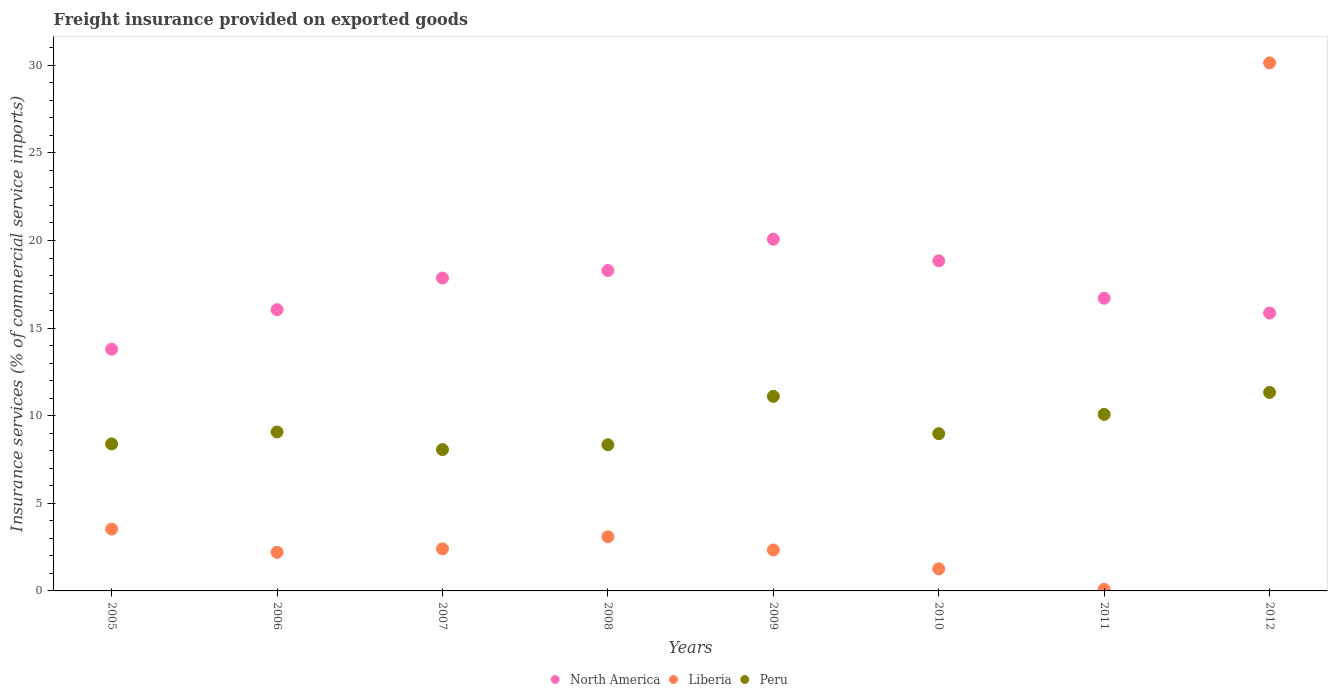How many different coloured dotlines are there?
Ensure brevity in your answer.  3. What is the freight insurance provided on exported goods in Liberia in 2012?
Give a very brief answer. 30.14. Across all years, what is the maximum freight insurance provided on exported goods in Peru?
Offer a terse response. 11.33. Across all years, what is the minimum freight insurance provided on exported goods in Liberia?
Your response must be concise. 0.09. In which year was the freight insurance provided on exported goods in Liberia maximum?
Provide a short and direct response. 2012. What is the total freight insurance provided on exported goods in North America in the graph?
Provide a short and direct response. 137.48. What is the difference between the freight insurance provided on exported goods in Liberia in 2010 and that in 2011?
Make the answer very short. 1.17. What is the difference between the freight insurance provided on exported goods in North America in 2011 and the freight insurance provided on exported goods in Liberia in 2007?
Make the answer very short. 14.3. What is the average freight insurance provided on exported goods in Liberia per year?
Make the answer very short. 5.63. In the year 2005, what is the difference between the freight insurance provided on exported goods in Peru and freight insurance provided on exported goods in Liberia?
Give a very brief answer. 4.86. What is the ratio of the freight insurance provided on exported goods in Liberia in 2006 to that in 2009?
Keep it short and to the point. 0.94. What is the difference between the highest and the second highest freight insurance provided on exported goods in Liberia?
Make the answer very short. 26.61. What is the difference between the highest and the lowest freight insurance provided on exported goods in Peru?
Make the answer very short. 3.26. In how many years, is the freight insurance provided on exported goods in Peru greater than the average freight insurance provided on exported goods in Peru taken over all years?
Provide a short and direct response. 3. Does the freight insurance provided on exported goods in North America monotonically increase over the years?
Your answer should be very brief. No. Is the freight insurance provided on exported goods in Liberia strictly greater than the freight insurance provided on exported goods in North America over the years?
Your response must be concise. No. Is the freight insurance provided on exported goods in North America strictly less than the freight insurance provided on exported goods in Peru over the years?
Make the answer very short. No. How many years are there in the graph?
Your answer should be compact. 8. Are the values on the major ticks of Y-axis written in scientific E-notation?
Your answer should be very brief. No. Does the graph contain any zero values?
Your response must be concise. No. Where does the legend appear in the graph?
Provide a short and direct response. Bottom center. What is the title of the graph?
Provide a succinct answer. Freight insurance provided on exported goods. What is the label or title of the Y-axis?
Your response must be concise. Insurance services (% of commercial service imports). What is the Insurance services (% of commercial service imports) of North America in 2005?
Your answer should be very brief. 13.8. What is the Insurance services (% of commercial service imports) in Liberia in 2005?
Make the answer very short. 3.53. What is the Insurance services (% of commercial service imports) in Peru in 2005?
Give a very brief answer. 8.39. What is the Insurance services (% of commercial service imports) in North America in 2006?
Make the answer very short. 16.05. What is the Insurance services (% of commercial service imports) in Liberia in 2006?
Your response must be concise. 2.2. What is the Insurance services (% of commercial service imports) of Peru in 2006?
Your answer should be compact. 9.07. What is the Insurance services (% of commercial service imports) of North America in 2007?
Offer a very short reply. 17.86. What is the Insurance services (% of commercial service imports) of Liberia in 2007?
Your answer should be very brief. 2.4. What is the Insurance services (% of commercial service imports) in Peru in 2007?
Make the answer very short. 8.07. What is the Insurance services (% of commercial service imports) in North America in 2008?
Your answer should be compact. 18.29. What is the Insurance services (% of commercial service imports) in Liberia in 2008?
Your answer should be compact. 3.09. What is the Insurance services (% of commercial service imports) of Peru in 2008?
Your answer should be very brief. 8.34. What is the Insurance services (% of commercial service imports) in North America in 2009?
Your answer should be compact. 20.08. What is the Insurance services (% of commercial service imports) in Liberia in 2009?
Provide a short and direct response. 2.34. What is the Insurance services (% of commercial service imports) in Peru in 2009?
Ensure brevity in your answer.  11.1. What is the Insurance services (% of commercial service imports) in North America in 2010?
Offer a very short reply. 18.84. What is the Insurance services (% of commercial service imports) in Liberia in 2010?
Your response must be concise. 1.26. What is the Insurance services (% of commercial service imports) of Peru in 2010?
Offer a terse response. 8.98. What is the Insurance services (% of commercial service imports) of North America in 2011?
Give a very brief answer. 16.7. What is the Insurance services (% of commercial service imports) in Liberia in 2011?
Offer a very short reply. 0.09. What is the Insurance services (% of commercial service imports) of Peru in 2011?
Offer a terse response. 10.08. What is the Insurance services (% of commercial service imports) of North America in 2012?
Your response must be concise. 15.86. What is the Insurance services (% of commercial service imports) in Liberia in 2012?
Offer a very short reply. 30.14. What is the Insurance services (% of commercial service imports) in Peru in 2012?
Make the answer very short. 11.33. Across all years, what is the maximum Insurance services (% of commercial service imports) of North America?
Make the answer very short. 20.08. Across all years, what is the maximum Insurance services (% of commercial service imports) in Liberia?
Your answer should be very brief. 30.14. Across all years, what is the maximum Insurance services (% of commercial service imports) in Peru?
Keep it short and to the point. 11.33. Across all years, what is the minimum Insurance services (% of commercial service imports) in North America?
Keep it short and to the point. 13.8. Across all years, what is the minimum Insurance services (% of commercial service imports) of Liberia?
Your answer should be compact. 0.09. Across all years, what is the minimum Insurance services (% of commercial service imports) in Peru?
Make the answer very short. 8.07. What is the total Insurance services (% of commercial service imports) in North America in the graph?
Offer a terse response. 137.48. What is the total Insurance services (% of commercial service imports) of Liberia in the graph?
Make the answer very short. 45.05. What is the total Insurance services (% of commercial service imports) of Peru in the graph?
Ensure brevity in your answer.  75.35. What is the difference between the Insurance services (% of commercial service imports) of North America in 2005 and that in 2006?
Offer a very short reply. -2.26. What is the difference between the Insurance services (% of commercial service imports) of Liberia in 2005 and that in 2006?
Provide a succinct answer. 1.33. What is the difference between the Insurance services (% of commercial service imports) in Peru in 2005 and that in 2006?
Ensure brevity in your answer.  -0.68. What is the difference between the Insurance services (% of commercial service imports) in North America in 2005 and that in 2007?
Keep it short and to the point. -4.06. What is the difference between the Insurance services (% of commercial service imports) in Liberia in 2005 and that in 2007?
Your answer should be compact. 1.13. What is the difference between the Insurance services (% of commercial service imports) of Peru in 2005 and that in 2007?
Offer a very short reply. 0.32. What is the difference between the Insurance services (% of commercial service imports) of North America in 2005 and that in 2008?
Your answer should be very brief. -4.49. What is the difference between the Insurance services (% of commercial service imports) in Liberia in 2005 and that in 2008?
Offer a very short reply. 0.44. What is the difference between the Insurance services (% of commercial service imports) in Peru in 2005 and that in 2008?
Your response must be concise. 0.05. What is the difference between the Insurance services (% of commercial service imports) of North America in 2005 and that in 2009?
Keep it short and to the point. -6.28. What is the difference between the Insurance services (% of commercial service imports) of Liberia in 2005 and that in 2009?
Keep it short and to the point. 1.19. What is the difference between the Insurance services (% of commercial service imports) of Peru in 2005 and that in 2009?
Ensure brevity in your answer.  -2.72. What is the difference between the Insurance services (% of commercial service imports) in North America in 2005 and that in 2010?
Your answer should be very brief. -5.04. What is the difference between the Insurance services (% of commercial service imports) of Liberia in 2005 and that in 2010?
Provide a short and direct response. 2.27. What is the difference between the Insurance services (% of commercial service imports) of Peru in 2005 and that in 2010?
Your answer should be very brief. -0.59. What is the difference between the Insurance services (% of commercial service imports) of North America in 2005 and that in 2011?
Your answer should be very brief. -2.91. What is the difference between the Insurance services (% of commercial service imports) in Liberia in 2005 and that in 2011?
Provide a short and direct response. 3.44. What is the difference between the Insurance services (% of commercial service imports) of Peru in 2005 and that in 2011?
Make the answer very short. -1.69. What is the difference between the Insurance services (% of commercial service imports) of North America in 2005 and that in 2012?
Your answer should be compact. -2.06. What is the difference between the Insurance services (% of commercial service imports) in Liberia in 2005 and that in 2012?
Provide a succinct answer. -26.61. What is the difference between the Insurance services (% of commercial service imports) in Peru in 2005 and that in 2012?
Provide a short and direct response. -2.94. What is the difference between the Insurance services (% of commercial service imports) of North America in 2006 and that in 2007?
Ensure brevity in your answer.  -1.81. What is the difference between the Insurance services (% of commercial service imports) in Liberia in 2006 and that in 2007?
Your answer should be very brief. -0.2. What is the difference between the Insurance services (% of commercial service imports) in Peru in 2006 and that in 2007?
Your answer should be very brief. 1.01. What is the difference between the Insurance services (% of commercial service imports) of North America in 2006 and that in 2008?
Make the answer very short. -2.24. What is the difference between the Insurance services (% of commercial service imports) in Liberia in 2006 and that in 2008?
Provide a short and direct response. -0.89. What is the difference between the Insurance services (% of commercial service imports) of Peru in 2006 and that in 2008?
Your response must be concise. 0.73. What is the difference between the Insurance services (% of commercial service imports) in North America in 2006 and that in 2009?
Your answer should be very brief. -4.02. What is the difference between the Insurance services (% of commercial service imports) of Liberia in 2006 and that in 2009?
Ensure brevity in your answer.  -0.13. What is the difference between the Insurance services (% of commercial service imports) of Peru in 2006 and that in 2009?
Give a very brief answer. -2.03. What is the difference between the Insurance services (% of commercial service imports) of North America in 2006 and that in 2010?
Ensure brevity in your answer.  -2.79. What is the difference between the Insurance services (% of commercial service imports) of Liberia in 2006 and that in 2010?
Keep it short and to the point. 0.94. What is the difference between the Insurance services (% of commercial service imports) in Peru in 2006 and that in 2010?
Offer a very short reply. 0.1. What is the difference between the Insurance services (% of commercial service imports) in North America in 2006 and that in 2011?
Your answer should be compact. -0.65. What is the difference between the Insurance services (% of commercial service imports) in Liberia in 2006 and that in 2011?
Your answer should be very brief. 2.11. What is the difference between the Insurance services (% of commercial service imports) of Peru in 2006 and that in 2011?
Offer a very short reply. -1. What is the difference between the Insurance services (% of commercial service imports) in North America in 2006 and that in 2012?
Your response must be concise. 0.19. What is the difference between the Insurance services (% of commercial service imports) of Liberia in 2006 and that in 2012?
Ensure brevity in your answer.  -27.93. What is the difference between the Insurance services (% of commercial service imports) of Peru in 2006 and that in 2012?
Make the answer very short. -2.26. What is the difference between the Insurance services (% of commercial service imports) in North America in 2007 and that in 2008?
Provide a short and direct response. -0.43. What is the difference between the Insurance services (% of commercial service imports) in Liberia in 2007 and that in 2008?
Ensure brevity in your answer.  -0.69. What is the difference between the Insurance services (% of commercial service imports) of Peru in 2007 and that in 2008?
Keep it short and to the point. -0.27. What is the difference between the Insurance services (% of commercial service imports) in North America in 2007 and that in 2009?
Make the answer very short. -2.22. What is the difference between the Insurance services (% of commercial service imports) in Liberia in 2007 and that in 2009?
Give a very brief answer. 0.06. What is the difference between the Insurance services (% of commercial service imports) of Peru in 2007 and that in 2009?
Give a very brief answer. -3.04. What is the difference between the Insurance services (% of commercial service imports) of North America in 2007 and that in 2010?
Provide a succinct answer. -0.98. What is the difference between the Insurance services (% of commercial service imports) of Liberia in 2007 and that in 2010?
Provide a short and direct response. 1.14. What is the difference between the Insurance services (% of commercial service imports) of Peru in 2007 and that in 2010?
Ensure brevity in your answer.  -0.91. What is the difference between the Insurance services (% of commercial service imports) in North America in 2007 and that in 2011?
Your response must be concise. 1.15. What is the difference between the Insurance services (% of commercial service imports) in Liberia in 2007 and that in 2011?
Ensure brevity in your answer.  2.31. What is the difference between the Insurance services (% of commercial service imports) of Peru in 2007 and that in 2011?
Your response must be concise. -2.01. What is the difference between the Insurance services (% of commercial service imports) of North America in 2007 and that in 2012?
Offer a very short reply. 2. What is the difference between the Insurance services (% of commercial service imports) of Liberia in 2007 and that in 2012?
Provide a short and direct response. -27.73. What is the difference between the Insurance services (% of commercial service imports) of Peru in 2007 and that in 2012?
Your answer should be compact. -3.26. What is the difference between the Insurance services (% of commercial service imports) of North America in 2008 and that in 2009?
Make the answer very short. -1.79. What is the difference between the Insurance services (% of commercial service imports) in Liberia in 2008 and that in 2009?
Offer a very short reply. 0.75. What is the difference between the Insurance services (% of commercial service imports) in Peru in 2008 and that in 2009?
Keep it short and to the point. -2.76. What is the difference between the Insurance services (% of commercial service imports) of North America in 2008 and that in 2010?
Ensure brevity in your answer.  -0.55. What is the difference between the Insurance services (% of commercial service imports) of Liberia in 2008 and that in 2010?
Your answer should be compact. 1.83. What is the difference between the Insurance services (% of commercial service imports) in Peru in 2008 and that in 2010?
Your response must be concise. -0.63. What is the difference between the Insurance services (% of commercial service imports) of North America in 2008 and that in 2011?
Your answer should be compact. 1.58. What is the difference between the Insurance services (% of commercial service imports) of Liberia in 2008 and that in 2011?
Offer a very short reply. 3. What is the difference between the Insurance services (% of commercial service imports) in Peru in 2008 and that in 2011?
Your answer should be compact. -1.74. What is the difference between the Insurance services (% of commercial service imports) in North America in 2008 and that in 2012?
Provide a short and direct response. 2.43. What is the difference between the Insurance services (% of commercial service imports) of Liberia in 2008 and that in 2012?
Provide a succinct answer. -27.05. What is the difference between the Insurance services (% of commercial service imports) in Peru in 2008 and that in 2012?
Offer a very short reply. -2.99. What is the difference between the Insurance services (% of commercial service imports) in North America in 2009 and that in 2010?
Provide a short and direct response. 1.24. What is the difference between the Insurance services (% of commercial service imports) of Liberia in 2009 and that in 2010?
Your response must be concise. 1.08. What is the difference between the Insurance services (% of commercial service imports) of Peru in 2009 and that in 2010?
Offer a very short reply. 2.13. What is the difference between the Insurance services (% of commercial service imports) of North America in 2009 and that in 2011?
Make the answer very short. 3.37. What is the difference between the Insurance services (% of commercial service imports) of Liberia in 2009 and that in 2011?
Offer a terse response. 2.25. What is the difference between the Insurance services (% of commercial service imports) in Peru in 2009 and that in 2011?
Make the answer very short. 1.03. What is the difference between the Insurance services (% of commercial service imports) in North America in 2009 and that in 2012?
Provide a succinct answer. 4.21. What is the difference between the Insurance services (% of commercial service imports) of Liberia in 2009 and that in 2012?
Your answer should be very brief. -27.8. What is the difference between the Insurance services (% of commercial service imports) of Peru in 2009 and that in 2012?
Your response must be concise. -0.23. What is the difference between the Insurance services (% of commercial service imports) of North America in 2010 and that in 2011?
Keep it short and to the point. 2.13. What is the difference between the Insurance services (% of commercial service imports) in Liberia in 2010 and that in 2011?
Offer a very short reply. 1.17. What is the difference between the Insurance services (% of commercial service imports) of Peru in 2010 and that in 2011?
Offer a very short reply. -1.1. What is the difference between the Insurance services (% of commercial service imports) of North America in 2010 and that in 2012?
Offer a terse response. 2.98. What is the difference between the Insurance services (% of commercial service imports) of Liberia in 2010 and that in 2012?
Your answer should be compact. -28.88. What is the difference between the Insurance services (% of commercial service imports) in Peru in 2010 and that in 2012?
Make the answer very short. -2.36. What is the difference between the Insurance services (% of commercial service imports) of North America in 2011 and that in 2012?
Provide a succinct answer. 0.84. What is the difference between the Insurance services (% of commercial service imports) of Liberia in 2011 and that in 2012?
Your answer should be compact. -30.05. What is the difference between the Insurance services (% of commercial service imports) in Peru in 2011 and that in 2012?
Ensure brevity in your answer.  -1.25. What is the difference between the Insurance services (% of commercial service imports) in North America in 2005 and the Insurance services (% of commercial service imports) in Liberia in 2006?
Your answer should be very brief. 11.59. What is the difference between the Insurance services (% of commercial service imports) of North America in 2005 and the Insurance services (% of commercial service imports) of Peru in 2006?
Keep it short and to the point. 4.72. What is the difference between the Insurance services (% of commercial service imports) of Liberia in 2005 and the Insurance services (% of commercial service imports) of Peru in 2006?
Your response must be concise. -5.54. What is the difference between the Insurance services (% of commercial service imports) in North America in 2005 and the Insurance services (% of commercial service imports) in Liberia in 2007?
Make the answer very short. 11.39. What is the difference between the Insurance services (% of commercial service imports) in North America in 2005 and the Insurance services (% of commercial service imports) in Peru in 2007?
Provide a short and direct response. 5.73. What is the difference between the Insurance services (% of commercial service imports) in Liberia in 2005 and the Insurance services (% of commercial service imports) in Peru in 2007?
Offer a terse response. -4.54. What is the difference between the Insurance services (% of commercial service imports) of North America in 2005 and the Insurance services (% of commercial service imports) of Liberia in 2008?
Offer a very short reply. 10.7. What is the difference between the Insurance services (% of commercial service imports) in North America in 2005 and the Insurance services (% of commercial service imports) in Peru in 2008?
Provide a succinct answer. 5.46. What is the difference between the Insurance services (% of commercial service imports) of Liberia in 2005 and the Insurance services (% of commercial service imports) of Peru in 2008?
Your response must be concise. -4.81. What is the difference between the Insurance services (% of commercial service imports) in North America in 2005 and the Insurance services (% of commercial service imports) in Liberia in 2009?
Keep it short and to the point. 11.46. What is the difference between the Insurance services (% of commercial service imports) of North America in 2005 and the Insurance services (% of commercial service imports) of Peru in 2009?
Provide a succinct answer. 2.69. What is the difference between the Insurance services (% of commercial service imports) in Liberia in 2005 and the Insurance services (% of commercial service imports) in Peru in 2009?
Give a very brief answer. -7.57. What is the difference between the Insurance services (% of commercial service imports) of North America in 2005 and the Insurance services (% of commercial service imports) of Liberia in 2010?
Provide a short and direct response. 12.54. What is the difference between the Insurance services (% of commercial service imports) in North America in 2005 and the Insurance services (% of commercial service imports) in Peru in 2010?
Keep it short and to the point. 4.82. What is the difference between the Insurance services (% of commercial service imports) in Liberia in 2005 and the Insurance services (% of commercial service imports) in Peru in 2010?
Your response must be concise. -5.44. What is the difference between the Insurance services (% of commercial service imports) of North America in 2005 and the Insurance services (% of commercial service imports) of Liberia in 2011?
Your answer should be very brief. 13.71. What is the difference between the Insurance services (% of commercial service imports) in North America in 2005 and the Insurance services (% of commercial service imports) in Peru in 2011?
Ensure brevity in your answer.  3.72. What is the difference between the Insurance services (% of commercial service imports) of Liberia in 2005 and the Insurance services (% of commercial service imports) of Peru in 2011?
Provide a succinct answer. -6.55. What is the difference between the Insurance services (% of commercial service imports) in North America in 2005 and the Insurance services (% of commercial service imports) in Liberia in 2012?
Make the answer very short. -16.34. What is the difference between the Insurance services (% of commercial service imports) in North America in 2005 and the Insurance services (% of commercial service imports) in Peru in 2012?
Provide a short and direct response. 2.47. What is the difference between the Insurance services (% of commercial service imports) of Liberia in 2005 and the Insurance services (% of commercial service imports) of Peru in 2012?
Keep it short and to the point. -7.8. What is the difference between the Insurance services (% of commercial service imports) in North America in 2006 and the Insurance services (% of commercial service imports) in Liberia in 2007?
Provide a succinct answer. 13.65. What is the difference between the Insurance services (% of commercial service imports) of North America in 2006 and the Insurance services (% of commercial service imports) of Peru in 2007?
Your answer should be very brief. 7.99. What is the difference between the Insurance services (% of commercial service imports) of Liberia in 2006 and the Insurance services (% of commercial service imports) of Peru in 2007?
Ensure brevity in your answer.  -5.86. What is the difference between the Insurance services (% of commercial service imports) in North America in 2006 and the Insurance services (% of commercial service imports) in Liberia in 2008?
Ensure brevity in your answer.  12.96. What is the difference between the Insurance services (% of commercial service imports) in North America in 2006 and the Insurance services (% of commercial service imports) in Peru in 2008?
Offer a terse response. 7.71. What is the difference between the Insurance services (% of commercial service imports) of Liberia in 2006 and the Insurance services (% of commercial service imports) of Peru in 2008?
Provide a short and direct response. -6.14. What is the difference between the Insurance services (% of commercial service imports) of North America in 2006 and the Insurance services (% of commercial service imports) of Liberia in 2009?
Offer a very short reply. 13.71. What is the difference between the Insurance services (% of commercial service imports) of North America in 2006 and the Insurance services (% of commercial service imports) of Peru in 2009?
Offer a very short reply. 4.95. What is the difference between the Insurance services (% of commercial service imports) of Liberia in 2006 and the Insurance services (% of commercial service imports) of Peru in 2009?
Make the answer very short. -8.9. What is the difference between the Insurance services (% of commercial service imports) of North America in 2006 and the Insurance services (% of commercial service imports) of Liberia in 2010?
Offer a terse response. 14.79. What is the difference between the Insurance services (% of commercial service imports) in North America in 2006 and the Insurance services (% of commercial service imports) in Peru in 2010?
Provide a short and direct response. 7.08. What is the difference between the Insurance services (% of commercial service imports) of Liberia in 2006 and the Insurance services (% of commercial service imports) of Peru in 2010?
Keep it short and to the point. -6.77. What is the difference between the Insurance services (% of commercial service imports) in North America in 2006 and the Insurance services (% of commercial service imports) in Liberia in 2011?
Your answer should be very brief. 15.96. What is the difference between the Insurance services (% of commercial service imports) in North America in 2006 and the Insurance services (% of commercial service imports) in Peru in 2011?
Your answer should be compact. 5.98. What is the difference between the Insurance services (% of commercial service imports) in Liberia in 2006 and the Insurance services (% of commercial service imports) in Peru in 2011?
Make the answer very short. -7.87. What is the difference between the Insurance services (% of commercial service imports) of North America in 2006 and the Insurance services (% of commercial service imports) of Liberia in 2012?
Provide a short and direct response. -14.09. What is the difference between the Insurance services (% of commercial service imports) in North America in 2006 and the Insurance services (% of commercial service imports) in Peru in 2012?
Keep it short and to the point. 4.72. What is the difference between the Insurance services (% of commercial service imports) in Liberia in 2006 and the Insurance services (% of commercial service imports) in Peru in 2012?
Offer a terse response. -9.13. What is the difference between the Insurance services (% of commercial service imports) of North America in 2007 and the Insurance services (% of commercial service imports) of Liberia in 2008?
Your response must be concise. 14.77. What is the difference between the Insurance services (% of commercial service imports) in North America in 2007 and the Insurance services (% of commercial service imports) in Peru in 2008?
Offer a terse response. 9.52. What is the difference between the Insurance services (% of commercial service imports) in Liberia in 2007 and the Insurance services (% of commercial service imports) in Peru in 2008?
Offer a terse response. -5.94. What is the difference between the Insurance services (% of commercial service imports) in North America in 2007 and the Insurance services (% of commercial service imports) in Liberia in 2009?
Keep it short and to the point. 15.52. What is the difference between the Insurance services (% of commercial service imports) in North America in 2007 and the Insurance services (% of commercial service imports) in Peru in 2009?
Give a very brief answer. 6.75. What is the difference between the Insurance services (% of commercial service imports) of Liberia in 2007 and the Insurance services (% of commercial service imports) of Peru in 2009?
Provide a short and direct response. -8.7. What is the difference between the Insurance services (% of commercial service imports) in North America in 2007 and the Insurance services (% of commercial service imports) in Liberia in 2010?
Ensure brevity in your answer.  16.6. What is the difference between the Insurance services (% of commercial service imports) of North America in 2007 and the Insurance services (% of commercial service imports) of Peru in 2010?
Offer a very short reply. 8.88. What is the difference between the Insurance services (% of commercial service imports) in Liberia in 2007 and the Insurance services (% of commercial service imports) in Peru in 2010?
Your answer should be very brief. -6.57. What is the difference between the Insurance services (% of commercial service imports) in North America in 2007 and the Insurance services (% of commercial service imports) in Liberia in 2011?
Your answer should be very brief. 17.77. What is the difference between the Insurance services (% of commercial service imports) in North America in 2007 and the Insurance services (% of commercial service imports) in Peru in 2011?
Offer a terse response. 7.78. What is the difference between the Insurance services (% of commercial service imports) in Liberia in 2007 and the Insurance services (% of commercial service imports) in Peru in 2011?
Provide a short and direct response. -7.67. What is the difference between the Insurance services (% of commercial service imports) in North America in 2007 and the Insurance services (% of commercial service imports) in Liberia in 2012?
Offer a terse response. -12.28. What is the difference between the Insurance services (% of commercial service imports) in North America in 2007 and the Insurance services (% of commercial service imports) in Peru in 2012?
Your answer should be compact. 6.53. What is the difference between the Insurance services (% of commercial service imports) in Liberia in 2007 and the Insurance services (% of commercial service imports) in Peru in 2012?
Your answer should be compact. -8.93. What is the difference between the Insurance services (% of commercial service imports) in North America in 2008 and the Insurance services (% of commercial service imports) in Liberia in 2009?
Ensure brevity in your answer.  15.95. What is the difference between the Insurance services (% of commercial service imports) of North America in 2008 and the Insurance services (% of commercial service imports) of Peru in 2009?
Give a very brief answer. 7.18. What is the difference between the Insurance services (% of commercial service imports) of Liberia in 2008 and the Insurance services (% of commercial service imports) of Peru in 2009?
Keep it short and to the point. -8.01. What is the difference between the Insurance services (% of commercial service imports) of North America in 2008 and the Insurance services (% of commercial service imports) of Liberia in 2010?
Your response must be concise. 17.03. What is the difference between the Insurance services (% of commercial service imports) in North America in 2008 and the Insurance services (% of commercial service imports) in Peru in 2010?
Your response must be concise. 9.31. What is the difference between the Insurance services (% of commercial service imports) of Liberia in 2008 and the Insurance services (% of commercial service imports) of Peru in 2010?
Offer a very short reply. -5.88. What is the difference between the Insurance services (% of commercial service imports) of North America in 2008 and the Insurance services (% of commercial service imports) of Liberia in 2011?
Give a very brief answer. 18.2. What is the difference between the Insurance services (% of commercial service imports) of North America in 2008 and the Insurance services (% of commercial service imports) of Peru in 2011?
Your response must be concise. 8.21. What is the difference between the Insurance services (% of commercial service imports) of Liberia in 2008 and the Insurance services (% of commercial service imports) of Peru in 2011?
Give a very brief answer. -6.98. What is the difference between the Insurance services (% of commercial service imports) of North America in 2008 and the Insurance services (% of commercial service imports) of Liberia in 2012?
Keep it short and to the point. -11.85. What is the difference between the Insurance services (% of commercial service imports) of North America in 2008 and the Insurance services (% of commercial service imports) of Peru in 2012?
Keep it short and to the point. 6.96. What is the difference between the Insurance services (% of commercial service imports) of Liberia in 2008 and the Insurance services (% of commercial service imports) of Peru in 2012?
Give a very brief answer. -8.24. What is the difference between the Insurance services (% of commercial service imports) in North America in 2009 and the Insurance services (% of commercial service imports) in Liberia in 2010?
Ensure brevity in your answer.  18.82. What is the difference between the Insurance services (% of commercial service imports) in North America in 2009 and the Insurance services (% of commercial service imports) in Peru in 2010?
Your answer should be compact. 11.1. What is the difference between the Insurance services (% of commercial service imports) in Liberia in 2009 and the Insurance services (% of commercial service imports) in Peru in 2010?
Keep it short and to the point. -6.64. What is the difference between the Insurance services (% of commercial service imports) of North America in 2009 and the Insurance services (% of commercial service imports) of Liberia in 2011?
Offer a very short reply. 19.98. What is the difference between the Insurance services (% of commercial service imports) of North America in 2009 and the Insurance services (% of commercial service imports) of Peru in 2011?
Provide a short and direct response. 10. What is the difference between the Insurance services (% of commercial service imports) in Liberia in 2009 and the Insurance services (% of commercial service imports) in Peru in 2011?
Keep it short and to the point. -7.74. What is the difference between the Insurance services (% of commercial service imports) of North America in 2009 and the Insurance services (% of commercial service imports) of Liberia in 2012?
Provide a short and direct response. -10.06. What is the difference between the Insurance services (% of commercial service imports) in North America in 2009 and the Insurance services (% of commercial service imports) in Peru in 2012?
Give a very brief answer. 8.74. What is the difference between the Insurance services (% of commercial service imports) of Liberia in 2009 and the Insurance services (% of commercial service imports) of Peru in 2012?
Offer a terse response. -8.99. What is the difference between the Insurance services (% of commercial service imports) in North America in 2010 and the Insurance services (% of commercial service imports) in Liberia in 2011?
Give a very brief answer. 18.75. What is the difference between the Insurance services (% of commercial service imports) in North America in 2010 and the Insurance services (% of commercial service imports) in Peru in 2011?
Provide a short and direct response. 8.76. What is the difference between the Insurance services (% of commercial service imports) of Liberia in 2010 and the Insurance services (% of commercial service imports) of Peru in 2011?
Provide a succinct answer. -8.82. What is the difference between the Insurance services (% of commercial service imports) in North America in 2010 and the Insurance services (% of commercial service imports) in Liberia in 2012?
Your answer should be compact. -11.3. What is the difference between the Insurance services (% of commercial service imports) in North America in 2010 and the Insurance services (% of commercial service imports) in Peru in 2012?
Offer a terse response. 7.51. What is the difference between the Insurance services (% of commercial service imports) in Liberia in 2010 and the Insurance services (% of commercial service imports) in Peru in 2012?
Keep it short and to the point. -10.07. What is the difference between the Insurance services (% of commercial service imports) in North America in 2011 and the Insurance services (% of commercial service imports) in Liberia in 2012?
Provide a short and direct response. -13.43. What is the difference between the Insurance services (% of commercial service imports) of North America in 2011 and the Insurance services (% of commercial service imports) of Peru in 2012?
Give a very brief answer. 5.37. What is the difference between the Insurance services (% of commercial service imports) of Liberia in 2011 and the Insurance services (% of commercial service imports) of Peru in 2012?
Ensure brevity in your answer.  -11.24. What is the average Insurance services (% of commercial service imports) of North America per year?
Provide a succinct answer. 17.18. What is the average Insurance services (% of commercial service imports) of Liberia per year?
Your response must be concise. 5.63. What is the average Insurance services (% of commercial service imports) in Peru per year?
Keep it short and to the point. 9.42. In the year 2005, what is the difference between the Insurance services (% of commercial service imports) of North America and Insurance services (% of commercial service imports) of Liberia?
Provide a succinct answer. 10.27. In the year 2005, what is the difference between the Insurance services (% of commercial service imports) in North America and Insurance services (% of commercial service imports) in Peru?
Provide a succinct answer. 5.41. In the year 2005, what is the difference between the Insurance services (% of commercial service imports) in Liberia and Insurance services (% of commercial service imports) in Peru?
Keep it short and to the point. -4.86. In the year 2006, what is the difference between the Insurance services (% of commercial service imports) of North America and Insurance services (% of commercial service imports) of Liberia?
Your answer should be very brief. 13.85. In the year 2006, what is the difference between the Insurance services (% of commercial service imports) of North America and Insurance services (% of commercial service imports) of Peru?
Provide a short and direct response. 6.98. In the year 2006, what is the difference between the Insurance services (% of commercial service imports) in Liberia and Insurance services (% of commercial service imports) in Peru?
Your answer should be compact. -6.87. In the year 2007, what is the difference between the Insurance services (% of commercial service imports) of North America and Insurance services (% of commercial service imports) of Liberia?
Keep it short and to the point. 15.46. In the year 2007, what is the difference between the Insurance services (% of commercial service imports) in North America and Insurance services (% of commercial service imports) in Peru?
Offer a terse response. 9.79. In the year 2007, what is the difference between the Insurance services (% of commercial service imports) in Liberia and Insurance services (% of commercial service imports) in Peru?
Offer a very short reply. -5.66. In the year 2008, what is the difference between the Insurance services (% of commercial service imports) of North America and Insurance services (% of commercial service imports) of Liberia?
Offer a very short reply. 15.2. In the year 2008, what is the difference between the Insurance services (% of commercial service imports) in North America and Insurance services (% of commercial service imports) in Peru?
Your answer should be very brief. 9.95. In the year 2008, what is the difference between the Insurance services (% of commercial service imports) in Liberia and Insurance services (% of commercial service imports) in Peru?
Provide a succinct answer. -5.25. In the year 2009, what is the difference between the Insurance services (% of commercial service imports) of North America and Insurance services (% of commercial service imports) of Liberia?
Ensure brevity in your answer.  17.74. In the year 2009, what is the difference between the Insurance services (% of commercial service imports) in North America and Insurance services (% of commercial service imports) in Peru?
Your answer should be very brief. 8.97. In the year 2009, what is the difference between the Insurance services (% of commercial service imports) of Liberia and Insurance services (% of commercial service imports) of Peru?
Keep it short and to the point. -8.77. In the year 2010, what is the difference between the Insurance services (% of commercial service imports) of North America and Insurance services (% of commercial service imports) of Liberia?
Your answer should be very brief. 17.58. In the year 2010, what is the difference between the Insurance services (% of commercial service imports) in North America and Insurance services (% of commercial service imports) in Peru?
Give a very brief answer. 9.86. In the year 2010, what is the difference between the Insurance services (% of commercial service imports) of Liberia and Insurance services (% of commercial service imports) of Peru?
Provide a short and direct response. -7.72. In the year 2011, what is the difference between the Insurance services (% of commercial service imports) of North America and Insurance services (% of commercial service imports) of Liberia?
Offer a very short reply. 16.61. In the year 2011, what is the difference between the Insurance services (% of commercial service imports) in North America and Insurance services (% of commercial service imports) in Peru?
Provide a short and direct response. 6.63. In the year 2011, what is the difference between the Insurance services (% of commercial service imports) of Liberia and Insurance services (% of commercial service imports) of Peru?
Keep it short and to the point. -9.99. In the year 2012, what is the difference between the Insurance services (% of commercial service imports) in North America and Insurance services (% of commercial service imports) in Liberia?
Provide a succinct answer. -14.28. In the year 2012, what is the difference between the Insurance services (% of commercial service imports) of North America and Insurance services (% of commercial service imports) of Peru?
Offer a very short reply. 4.53. In the year 2012, what is the difference between the Insurance services (% of commercial service imports) in Liberia and Insurance services (% of commercial service imports) in Peru?
Offer a very short reply. 18.81. What is the ratio of the Insurance services (% of commercial service imports) in North America in 2005 to that in 2006?
Offer a very short reply. 0.86. What is the ratio of the Insurance services (% of commercial service imports) in Liberia in 2005 to that in 2006?
Ensure brevity in your answer.  1.6. What is the ratio of the Insurance services (% of commercial service imports) of Peru in 2005 to that in 2006?
Keep it short and to the point. 0.92. What is the ratio of the Insurance services (% of commercial service imports) of North America in 2005 to that in 2007?
Provide a short and direct response. 0.77. What is the ratio of the Insurance services (% of commercial service imports) of Liberia in 2005 to that in 2007?
Offer a terse response. 1.47. What is the ratio of the Insurance services (% of commercial service imports) of Peru in 2005 to that in 2007?
Keep it short and to the point. 1.04. What is the ratio of the Insurance services (% of commercial service imports) of North America in 2005 to that in 2008?
Keep it short and to the point. 0.75. What is the ratio of the Insurance services (% of commercial service imports) in Liberia in 2005 to that in 2008?
Offer a terse response. 1.14. What is the ratio of the Insurance services (% of commercial service imports) of North America in 2005 to that in 2009?
Give a very brief answer. 0.69. What is the ratio of the Insurance services (% of commercial service imports) in Liberia in 2005 to that in 2009?
Provide a short and direct response. 1.51. What is the ratio of the Insurance services (% of commercial service imports) of Peru in 2005 to that in 2009?
Your response must be concise. 0.76. What is the ratio of the Insurance services (% of commercial service imports) of North America in 2005 to that in 2010?
Ensure brevity in your answer.  0.73. What is the ratio of the Insurance services (% of commercial service imports) of Liberia in 2005 to that in 2010?
Your response must be concise. 2.8. What is the ratio of the Insurance services (% of commercial service imports) in Peru in 2005 to that in 2010?
Make the answer very short. 0.93. What is the ratio of the Insurance services (% of commercial service imports) in North America in 2005 to that in 2011?
Ensure brevity in your answer.  0.83. What is the ratio of the Insurance services (% of commercial service imports) of Liberia in 2005 to that in 2011?
Provide a short and direct response. 39. What is the ratio of the Insurance services (% of commercial service imports) of Peru in 2005 to that in 2011?
Give a very brief answer. 0.83. What is the ratio of the Insurance services (% of commercial service imports) in North America in 2005 to that in 2012?
Provide a short and direct response. 0.87. What is the ratio of the Insurance services (% of commercial service imports) in Liberia in 2005 to that in 2012?
Your answer should be very brief. 0.12. What is the ratio of the Insurance services (% of commercial service imports) of Peru in 2005 to that in 2012?
Offer a terse response. 0.74. What is the ratio of the Insurance services (% of commercial service imports) of North America in 2006 to that in 2007?
Provide a succinct answer. 0.9. What is the ratio of the Insurance services (% of commercial service imports) of Liberia in 2006 to that in 2007?
Provide a short and direct response. 0.92. What is the ratio of the Insurance services (% of commercial service imports) in Peru in 2006 to that in 2007?
Offer a terse response. 1.12. What is the ratio of the Insurance services (% of commercial service imports) of North America in 2006 to that in 2008?
Your answer should be compact. 0.88. What is the ratio of the Insurance services (% of commercial service imports) of Liberia in 2006 to that in 2008?
Give a very brief answer. 0.71. What is the ratio of the Insurance services (% of commercial service imports) in Peru in 2006 to that in 2008?
Provide a short and direct response. 1.09. What is the ratio of the Insurance services (% of commercial service imports) of North America in 2006 to that in 2009?
Your answer should be very brief. 0.8. What is the ratio of the Insurance services (% of commercial service imports) in Liberia in 2006 to that in 2009?
Provide a short and direct response. 0.94. What is the ratio of the Insurance services (% of commercial service imports) of Peru in 2006 to that in 2009?
Give a very brief answer. 0.82. What is the ratio of the Insurance services (% of commercial service imports) in North America in 2006 to that in 2010?
Your answer should be very brief. 0.85. What is the ratio of the Insurance services (% of commercial service imports) of Liberia in 2006 to that in 2010?
Keep it short and to the point. 1.75. What is the ratio of the Insurance services (% of commercial service imports) in Peru in 2006 to that in 2010?
Ensure brevity in your answer.  1.01. What is the ratio of the Insurance services (% of commercial service imports) in North America in 2006 to that in 2011?
Keep it short and to the point. 0.96. What is the ratio of the Insurance services (% of commercial service imports) in Liberia in 2006 to that in 2011?
Provide a succinct answer. 24.34. What is the ratio of the Insurance services (% of commercial service imports) in Peru in 2006 to that in 2011?
Ensure brevity in your answer.  0.9. What is the ratio of the Insurance services (% of commercial service imports) of North America in 2006 to that in 2012?
Provide a succinct answer. 1.01. What is the ratio of the Insurance services (% of commercial service imports) of Liberia in 2006 to that in 2012?
Provide a short and direct response. 0.07. What is the ratio of the Insurance services (% of commercial service imports) of Peru in 2006 to that in 2012?
Offer a terse response. 0.8. What is the ratio of the Insurance services (% of commercial service imports) of North America in 2007 to that in 2008?
Offer a terse response. 0.98. What is the ratio of the Insurance services (% of commercial service imports) in Liberia in 2007 to that in 2008?
Offer a very short reply. 0.78. What is the ratio of the Insurance services (% of commercial service imports) in Peru in 2007 to that in 2008?
Provide a short and direct response. 0.97. What is the ratio of the Insurance services (% of commercial service imports) of North America in 2007 to that in 2009?
Your response must be concise. 0.89. What is the ratio of the Insurance services (% of commercial service imports) of Liberia in 2007 to that in 2009?
Make the answer very short. 1.03. What is the ratio of the Insurance services (% of commercial service imports) of Peru in 2007 to that in 2009?
Your answer should be very brief. 0.73. What is the ratio of the Insurance services (% of commercial service imports) of North America in 2007 to that in 2010?
Make the answer very short. 0.95. What is the ratio of the Insurance services (% of commercial service imports) in Liberia in 2007 to that in 2010?
Your response must be concise. 1.91. What is the ratio of the Insurance services (% of commercial service imports) of Peru in 2007 to that in 2010?
Your answer should be very brief. 0.9. What is the ratio of the Insurance services (% of commercial service imports) of North America in 2007 to that in 2011?
Your response must be concise. 1.07. What is the ratio of the Insurance services (% of commercial service imports) in Liberia in 2007 to that in 2011?
Your answer should be compact. 26.53. What is the ratio of the Insurance services (% of commercial service imports) in Peru in 2007 to that in 2011?
Keep it short and to the point. 0.8. What is the ratio of the Insurance services (% of commercial service imports) in North America in 2007 to that in 2012?
Offer a terse response. 1.13. What is the ratio of the Insurance services (% of commercial service imports) in Liberia in 2007 to that in 2012?
Make the answer very short. 0.08. What is the ratio of the Insurance services (% of commercial service imports) in Peru in 2007 to that in 2012?
Provide a short and direct response. 0.71. What is the ratio of the Insurance services (% of commercial service imports) in North America in 2008 to that in 2009?
Give a very brief answer. 0.91. What is the ratio of the Insurance services (% of commercial service imports) of Liberia in 2008 to that in 2009?
Provide a short and direct response. 1.32. What is the ratio of the Insurance services (% of commercial service imports) in Peru in 2008 to that in 2009?
Your answer should be very brief. 0.75. What is the ratio of the Insurance services (% of commercial service imports) in North America in 2008 to that in 2010?
Your answer should be very brief. 0.97. What is the ratio of the Insurance services (% of commercial service imports) of Liberia in 2008 to that in 2010?
Provide a succinct answer. 2.45. What is the ratio of the Insurance services (% of commercial service imports) of Peru in 2008 to that in 2010?
Make the answer very short. 0.93. What is the ratio of the Insurance services (% of commercial service imports) of North America in 2008 to that in 2011?
Keep it short and to the point. 1.09. What is the ratio of the Insurance services (% of commercial service imports) of Liberia in 2008 to that in 2011?
Ensure brevity in your answer.  34.15. What is the ratio of the Insurance services (% of commercial service imports) of Peru in 2008 to that in 2011?
Make the answer very short. 0.83. What is the ratio of the Insurance services (% of commercial service imports) in North America in 2008 to that in 2012?
Give a very brief answer. 1.15. What is the ratio of the Insurance services (% of commercial service imports) of Liberia in 2008 to that in 2012?
Offer a very short reply. 0.1. What is the ratio of the Insurance services (% of commercial service imports) in Peru in 2008 to that in 2012?
Your answer should be very brief. 0.74. What is the ratio of the Insurance services (% of commercial service imports) in North America in 2009 to that in 2010?
Your answer should be very brief. 1.07. What is the ratio of the Insurance services (% of commercial service imports) of Liberia in 2009 to that in 2010?
Provide a succinct answer. 1.85. What is the ratio of the Insurance services (% of commercial service imports) of Peru in 2009 to that in 2010?
Make the answer very short. 1.24. What is the ratio of the Insurance services (% of commercial service imports) of North America in 2009 to that in 2011?
Your response must be concise. 1.2. What is the ratio of the Insurance services (% of commercial service imports) in Liberia in 2009 to that in 2011?
Ensure brevity in your answer.  25.81. What is the ratio of the Insurance services (% of commercial service imports) in Peru in 2009 to that in 2011?
Offer a very short reply. 1.1. What is the ratio of the Insurance services (% of commercial service imports) in North America in 2009 to that in 2012?
Provide a succinct answer. 1.27. What is the ratio of the Insurance services (% of commercial service imports) of Liberia in 2009 to that in 2012?
Your answer should be compact. 0.08. What is the ratio of the Insurance services (% of commercial service imports) in Peru in 2009 to that in 2012?
Provide a succinct answer. 0.98. What is the ratio of the Insurance services (% of commercial service imports) of North America in 2010 to that in 2011?
Your answer should be compact. 1.13. What is the ratio of the Insurance services (% of commercial service imports) in Liberia in 2010 to that in 2011?
Offer a terse response. 13.92. What is the ratio of the Insurance services (% of commercial service imports) of Peru in 2010 to that in 2011?
Your answer should be compact. 0.89. What is the ratio of the Insurance services (% of commercial service imports) in North America in 2010 to that in 2012?
Your answer should be very brief. 1.19. What is the ratio of the Insurance services (% of commercial service imports) in Liberia in 2010 to that in 2012?
Ensure brevity in your answer.  0.04. What is the ratio of the Insurance services (% of commercial service imports) in Peru in 2010 to that in 2012?
Your answer should be compact. 0.79. What is the ratio of the Insurance services (% of commercial service imports) in North America in 2011 to that in 2012?
Provide a short and direct response. 1.05. What is the ratio of the Insurance services (% of commercial service imports) of Liberia in 2011 to that in 2012?
Give a very brief answer. 0. What is the ratio of the Insurance services (% of commercial service imports) in Peru in 2011 to that in 2012?
Your response must be concise. 0.89. What is the difference between the highest and the second highest Insurance services (% of commercial service imports) in North America?
Provide a succinct answer. 1.24. What is the difference between the highest and the second highest Insurance services (% of commercial service imports) of Liberia?
Make the answer very short. 26.61. What is the difference between the highest and the second highest Insurance services (% of commercial service imports) of Peru?
Your answer should be compact. 0.23. What is the difference between the highest and the lowest Insurance services (% of commercial service imports) in North America?
Ensure brevity in your answer.  6.28. What is the difference between the highest and the lowest Insurance services (% of commercial service imports) of Liberia?
Give a very brief answer. 30.05. What is the difference between the highest and the lowest Insurance services (% of commercial service imports) in Peru?
Make the answer very short. 3.26. 